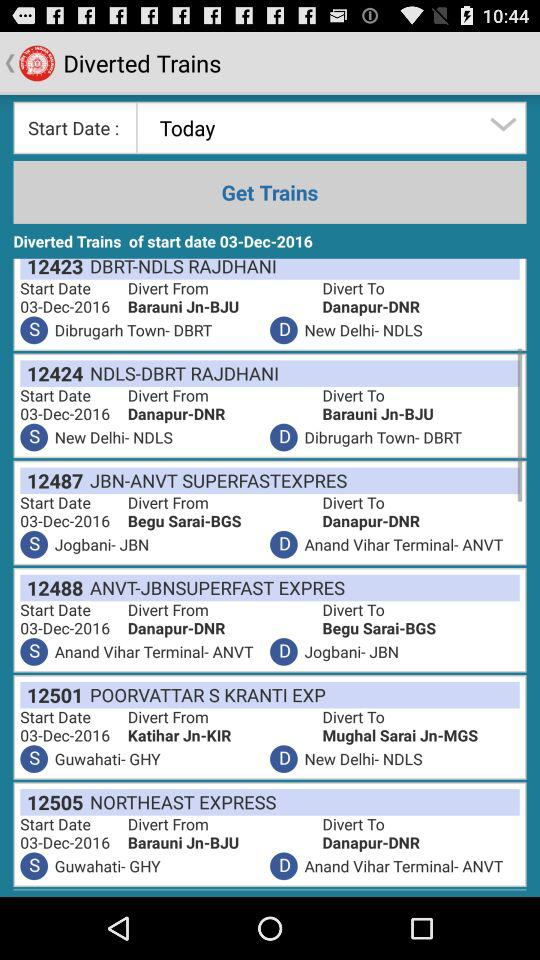Which is the given day? The given day is today. 